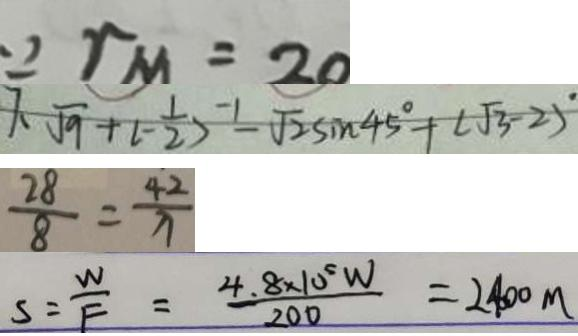<formula> <loc_0><loc_0><loc_500><loc_500>\because r m = 2 0 
 7 . \sqrt { 9 } + ( - \frac { 1 } { 2 } ) ^ { - 1 } - \sqrt { 2 } \sin 4 5 ^ { \circ } + ( \sqrt { 3 } - 2 ) ^ { \circ } 
 \frac { 2 8 } { 8 } = \frac { 4 2 } { x } 
 S = \frac { W } { F } = \frac { 4 . 8 \times 1 0 ^ { 5 } W } { 2 0 0 } = 2 4 0 0 m</formula> 